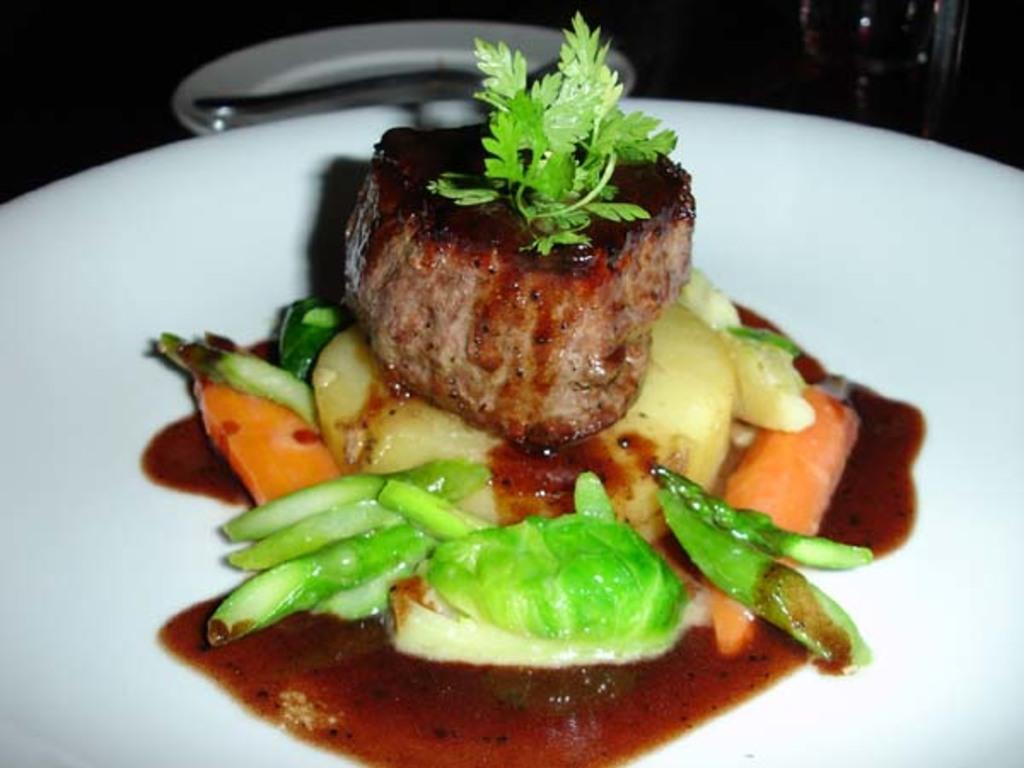In one or two sentences, can you explain what this image depicts? In this image there is a plate, in that place there is food item. 